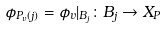Convert formula to latex. <formula><loc_0><loc_0><loc_500><loc_500>\phi _ { P _ { v } ( j ) } = \phi _ { v } | _ { B _ { j } } \colon B _ { j } \to X _ { P }</formula> 